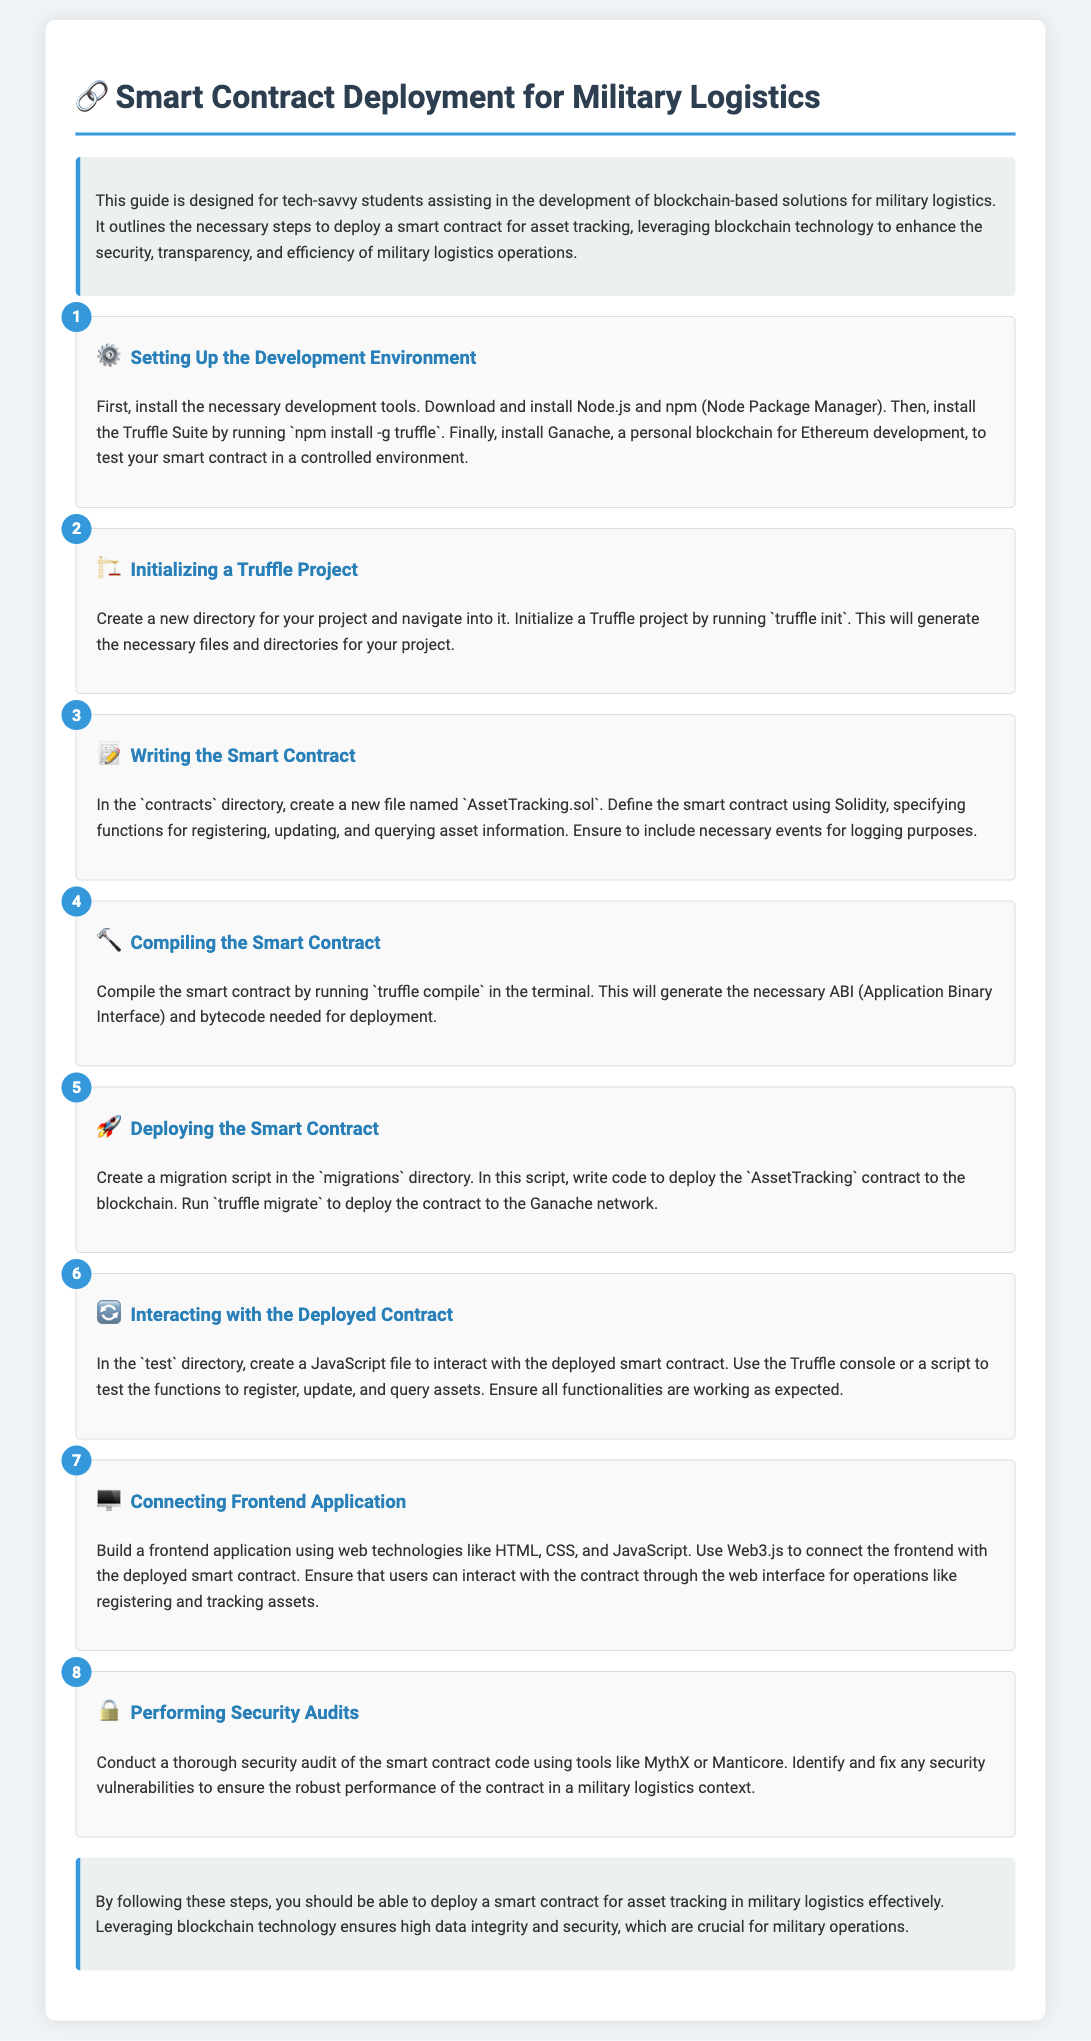What is the title of the document? The title is prominently displayed at the top of the document, clearly indicating the focus on smart contract deployment for military logistics.
Answer: Smart Contract Deployment for Military Logistics How many steps are listed in the deployment instructions? The document enumerates the steps under the 'steps' section, providing a clear count of the steps involved.
Answer: Eight What tool should be installed to compile the smart contract? The document specifies the necessary tools for the development environment, including the tool for compiling contracts.
Answer: Truffle Suite What is the first step in the deployment process? The first step is outlined in the document, specifically detailing the initial setup required for development.
Answer: Setting Up the Development Environment Which JavaScript library is mentioned for connecting the frontend application? The document indicates the specific library utilized for the frontend connection, pertinent to interacting with the deployed smart contract.
Answer: Web3.js What is suggested for conducting security audits? The document provides recommendations for tools that can be used for security audits of the smart contract code.
Answer: MythX or Manticore Where should the smart contract be written? The document indicates the specific directory within which the smart contract code should be created.
Answer: contracts directory What is the purpose of the 'truffle migrate' command? The document explains the command's function in deploying the written smart contract to the blockchain.
Answer: Deploying the Smart Contract 